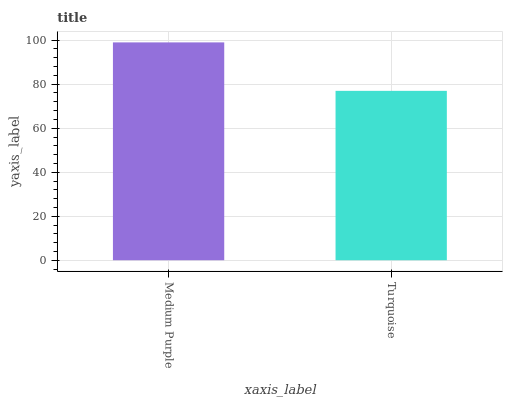Is Turquoise the minimum?
Answer yes or no. Yes. Is Medium Purple the maximum?
Answer yes or no. Yes. Is Turquoise the maximum?
Answer yes or no. No. Is Medium Purple greater than Turquoise?
Answer yes or no. Yes. Is Turquoise less than Medium Purple?
Answer yes or no. Yes. Is Turquoise greater than Medium Purple?
Answer yes or no. No. Is Medium Purple less than Turquoise?
Answer yes or no. No. Is Medium Purple the high median?
Answer yes or no. Yes. Is Turquoise the low median?
Answer yes or no. Yes. Is Turquoise the high median?
Answer yes or no. No. Is Medium Purple the low median?
Answer yes or no. No. 